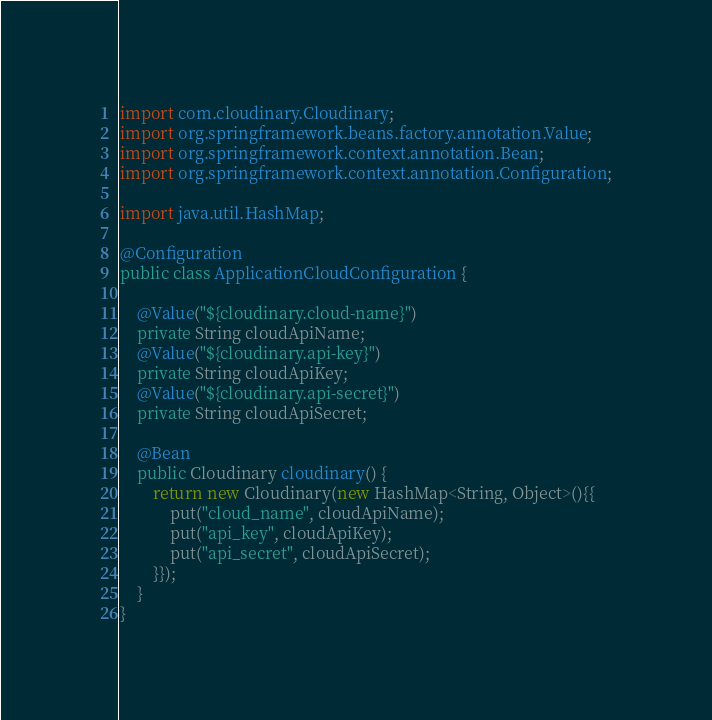<code> <loc_0><loc_0><loc_500><loc_500><_Java_>import com.cloudinary.Cloudinary;
import org.springframework.beans.factory.annotation.Value;
import org.springframework.context.annotation.Bean;
import org.springframework.context.annotation.Configuration;

import java.util.HashMap;

@Configuration
public class ApplicationCloudConfiguration {

    @Value("${cloudinary.cloud-name}")
    private String cloudApiName;
    @Value("${cloudinary.api-key}")
    private String cloudApiKey;
    @Value("${cloudinary.api-secret}")
    private String cloudApiSecret;

    @Bean
    public Cloudinary cloudinary() {
        return new Cloudinary(new HashMap<String, Object>(){{
            put("cloud_name", cloudApiName);
            put("api_key", cloudApiKey);
            put("api_secret", cloudApiSecret);
        }});
    }
}
</code> 